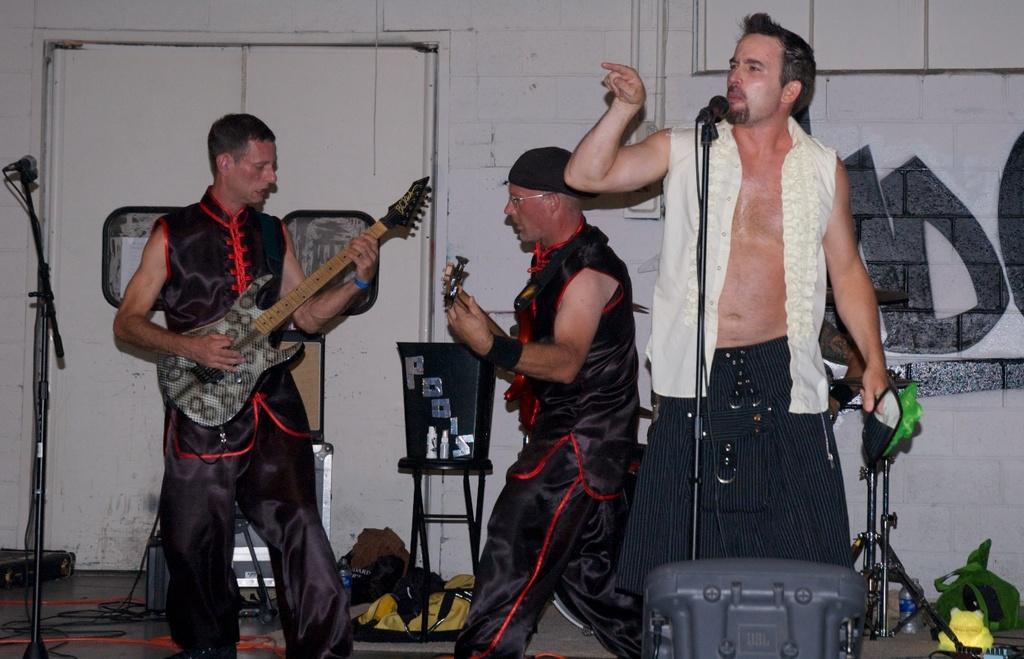In one or two sentences, can you explain what this image depicts? The picture is taken inside the room where three people are standing, at the right corner of the picture on person is wearing a skirt and white shirt and he is standing in front of a microphone and at the left corner of the picture one person is playing a guitar in a black dress and the person in the middle wearing a black dress and playing a guitar and behind them there are stools,bags,some stickers and a big wall and a door is present. 